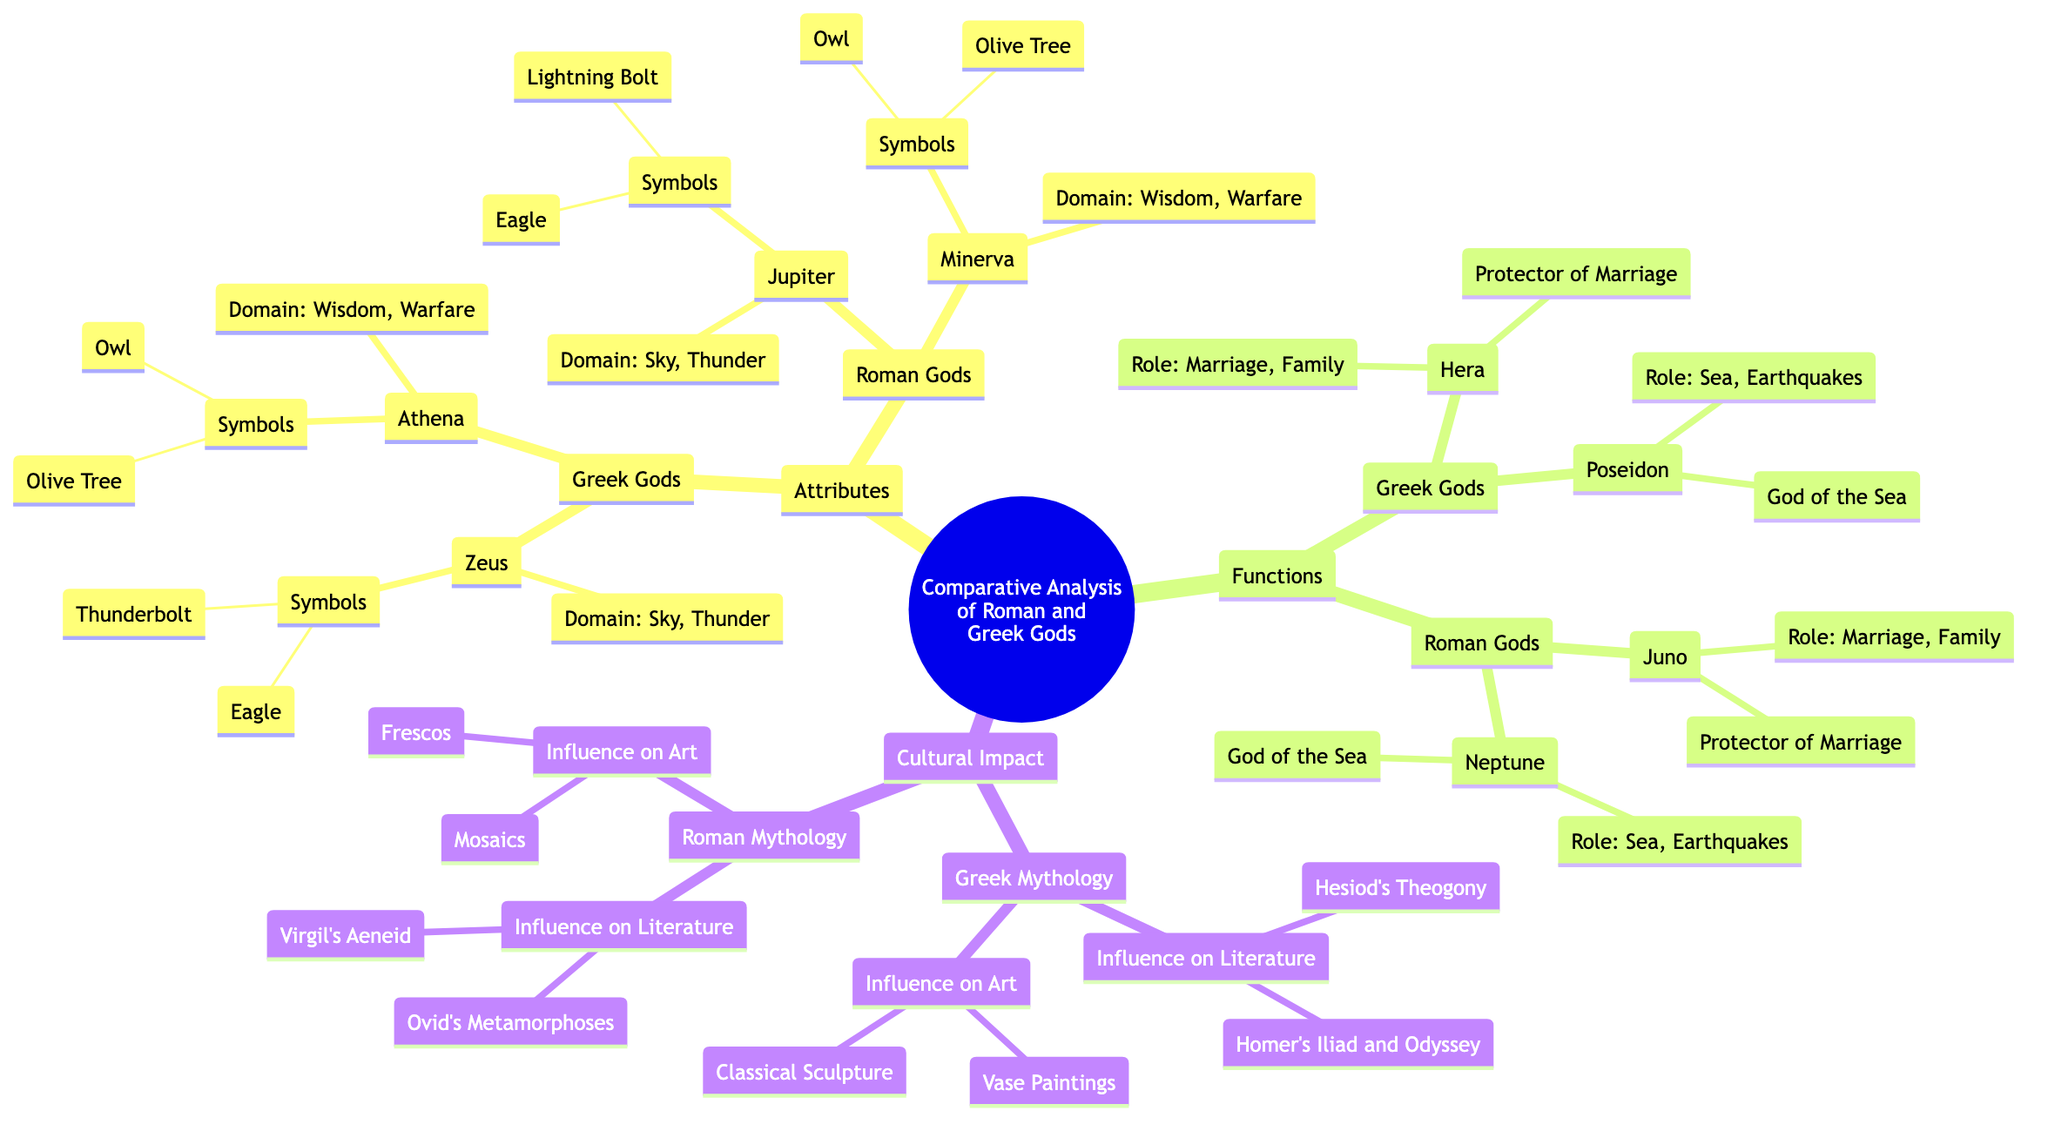What is the domain of Zeus? The domain of Zeus, as listed under Greek Gods in the Attributes section, is "Sky, Thunder."
Answer: Sky, Thunder How many symbols does Athena have? Athena has two symbols listed under Greek Gods in the Attributes section: "Owl" and "Olive Tree", which means the total is two.
Answer: 2 What is the role of Hera? Hera's role, as mentioned under Greek Gods in the Functions section, is "Marriage, Family."
Answer: Marriage, Family Which Roman God has a role similar to Poseidon? Poseidon, who has the role of "Sea, Earthquakes" in the Greek Gods Functions section, has a similar role to Neptune, listed under Roman Gods in the same section.
Answer: Neptune Name one literary work influenced by Greek mythology. Under the Cultural Impact section, one literary work influenced by Greek mythology is "Homer's Iliad and Odyssey."
Answer: Homer's Iliad and Odyssey How many Greek Gods are listed under Functions? There are two Greek gods listed under Functions: Hera and Poseidon, making the total count two.
Answer: 2 What symbol is shared by both Jupiter and Zeus? Both Jupiter and Zeus share the symbol "Eagle," which is noted under their respective descriptions in the Attributes section.
Answer: Eagle Which type of art is influenced by Roman mythology? The Cultural Impact section notes that "Mosaics" is one type of art influenced by Roman mythology.
Answer: Mosaics What attribute describes Juno's role? Juno, under Roman Gods in the Functions section, is also described as "Protector of Marriage," which reflects her attributes.
Answer: Protector of Marriage 